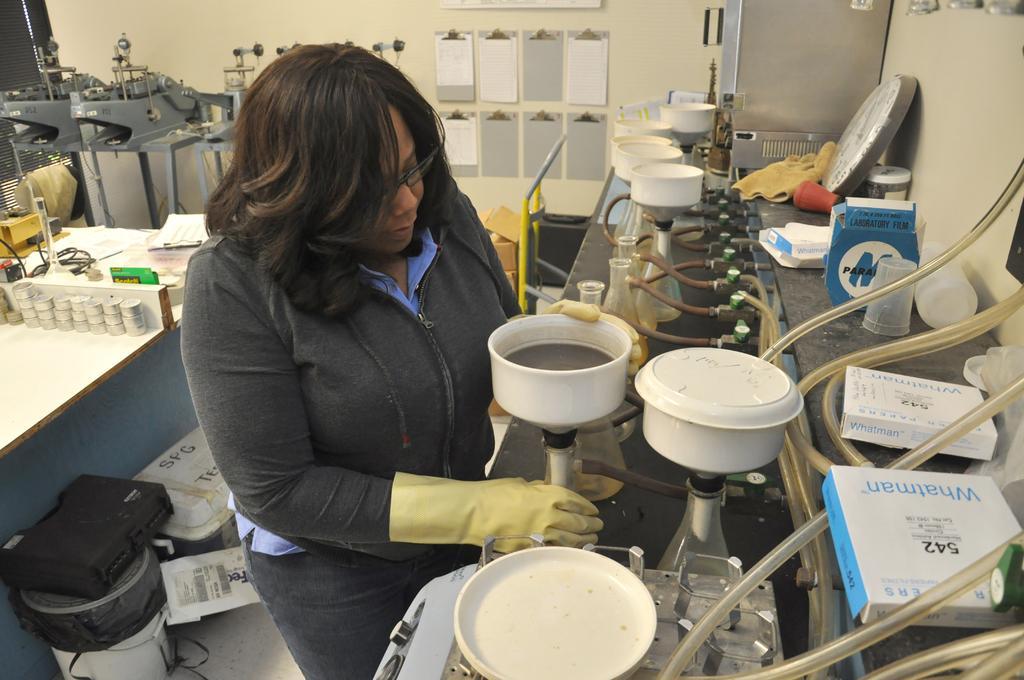In one or two sentences, can you explain what this image depicts? This image looks like a laboratory, in which I can see woman wearing gloves standing in front of table , on which there are wires, bowls, flasks, cloth, boxes, plate, in front of table there is the wall, at the top I can see the wall, on which there are papers attached, in front it there are machines, on the table, on which there are some other objects kept on it, in the bottom left there are boxes visible. 